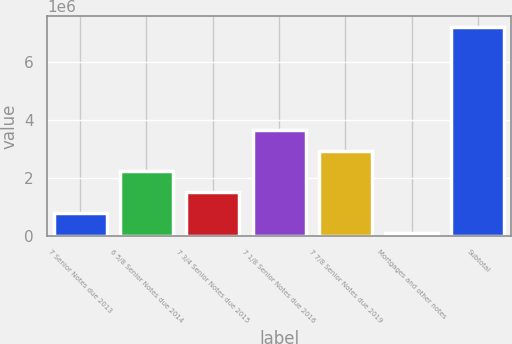<chart> <loc_0><loc_0><loc_500><loc_500><bar_chart><fcel>7 Senior Notes due 2013<fcel>6 5/8 Senior Notes due 2014<fcel>7 3/4 Senior Notes due 2015<fcel>7 1/8 Senior Notes due 2016<fcel>7 7/8 Senior Notes due 2019<fcel>Mortgages and other notes<fcel>Subtotal<nl><fcel>786871<fcel>2.21687e+06<fcel>1.50187e+06<fcel>3.64687e+06<fcel>2.93187e+06<fcel>71871<fcel>7.22187e+06<nl></chart> 